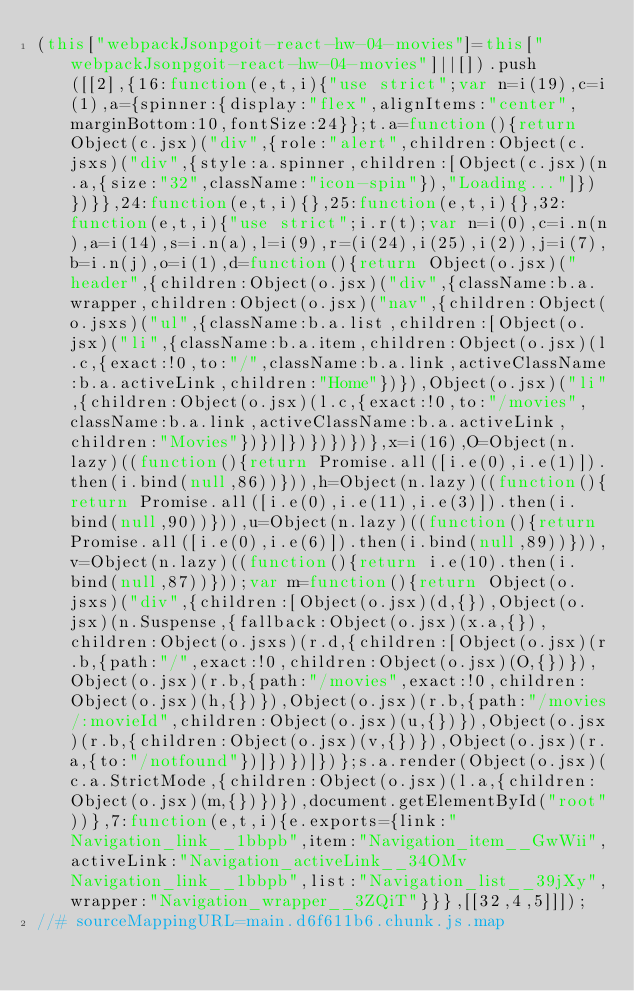Convert code to text. <code><loc_0><loc_0><loc_500><loc_500><_JavaScript_>(this["webpackJsonpgoit-react-hw-04-movies"]=this["webpackJsonpgoit-react-hw-04-movies"]||[]).push([[2],{16:function(e,t,i){"use strict";var n=i(19),c=i(1),a={spinner:{display:"flex",alignItems:"center",marginBottom:10,fontSize:24}};t.a=function(){return Object(c.jsx)("div",{role:"alert",children:Object(c.jsxs)("div",{style:a.spinner,children:[Object(c.jsx)(n.a,{size:"32",className:"icon-spin"}),"Loading..."]})})}},24:function(e,t,i){},25:function(e,t,i){},32:function(e,t,i){"use strict";i.r(t);var n=i(0),c=i.n(n),a=i(14),s=i.n(a),l=i(9),r=(i(24),i(25),i(2)),j=i(7),b=i.n(j),o=i(1),d=function(){return Object(o.jsx)("header",{children:Object(o.jsx)("div",{className:b.a.wrapper,children:Object(o.jsx)("nav",{children:Object(o.jsxs)("ul",{className:b.a.list,children:[Object(o.jsx)("li",{className:b.a.item,children:Object(o.jsx)(l.c,{exact:!0,to:"/",className:b.a.link,activeClassName:b.a.activeLink,children:"Home"})}),Object(o.jsx)("li",{children:Object(o.jsx)(l.c,{exact:!0,to:"/movies",className:b.a.link,activeClassName:b.a.activeLink,children:"Movies"})})]})})})})},x=i(16),O=Object(n.lazy)((function(){return Promise.all([i.e(0),i.e(1)]).then(i.bind(null,86))})),h=Object(n.lazy)((function(){return Promise.all([i.e(0),i.e(11),i.e(3)]).then(i.bind(null,90))})),u=Object(n.lazy)((function(){return Promise.all([i.e(0),i.e(6)]).then(i.bind(null,89))})),v=Object(n.lazy)((function(){return i.e(10).then(i.bind(null,87))}));var m=function(){return Object(o.jsxs)("div",{children:[Object(o.jsx)(d,{}),Object(o.jsx)(n.Suspense,{fallback:Object(o.jsx)(x.a,{}),children:Object(o.jsxs)(r.d,{children:[Object(o.jsx)(r.b,{path:"/",exact:!0,children:Object(o.jsx)(O,{})}),Object(o.jsx)(r.b,{path:"/movies",exact:!0,children:Object(o.jsx)(h,{})}),Object(o.jsx)(r.b,{path:"/movies/:movieId",children:Object(o.jsx)(u,{})}),Object(o.jsx)(r.b,{children:Object(o.jsx)(v,{})}),Object(o.jsx)(r.a,{to:"/notfound"})]})})]})};s.a.render(Object(o.jsx)(c.a.StrictMode,{children:Object(o.jsx)(l.a,{children:Object(o.jsx)(m,{})})}),document.getElementById("root"))},7:function(e,t,i){e.exports={link:"Navigation_link__1bbpb",item:"Navigation_item__GwWii",activeLink:"Navigation_activeLink__34OMv Navigation_link__1bbpb",list:"Navigation_list__39jXy",wrapper:"Navigation_wrapper__3ZQiT"}}},[[32,4,5]]]);
//# sourceMappingURL=main.d6f611b6.chunk.js.map</code> 